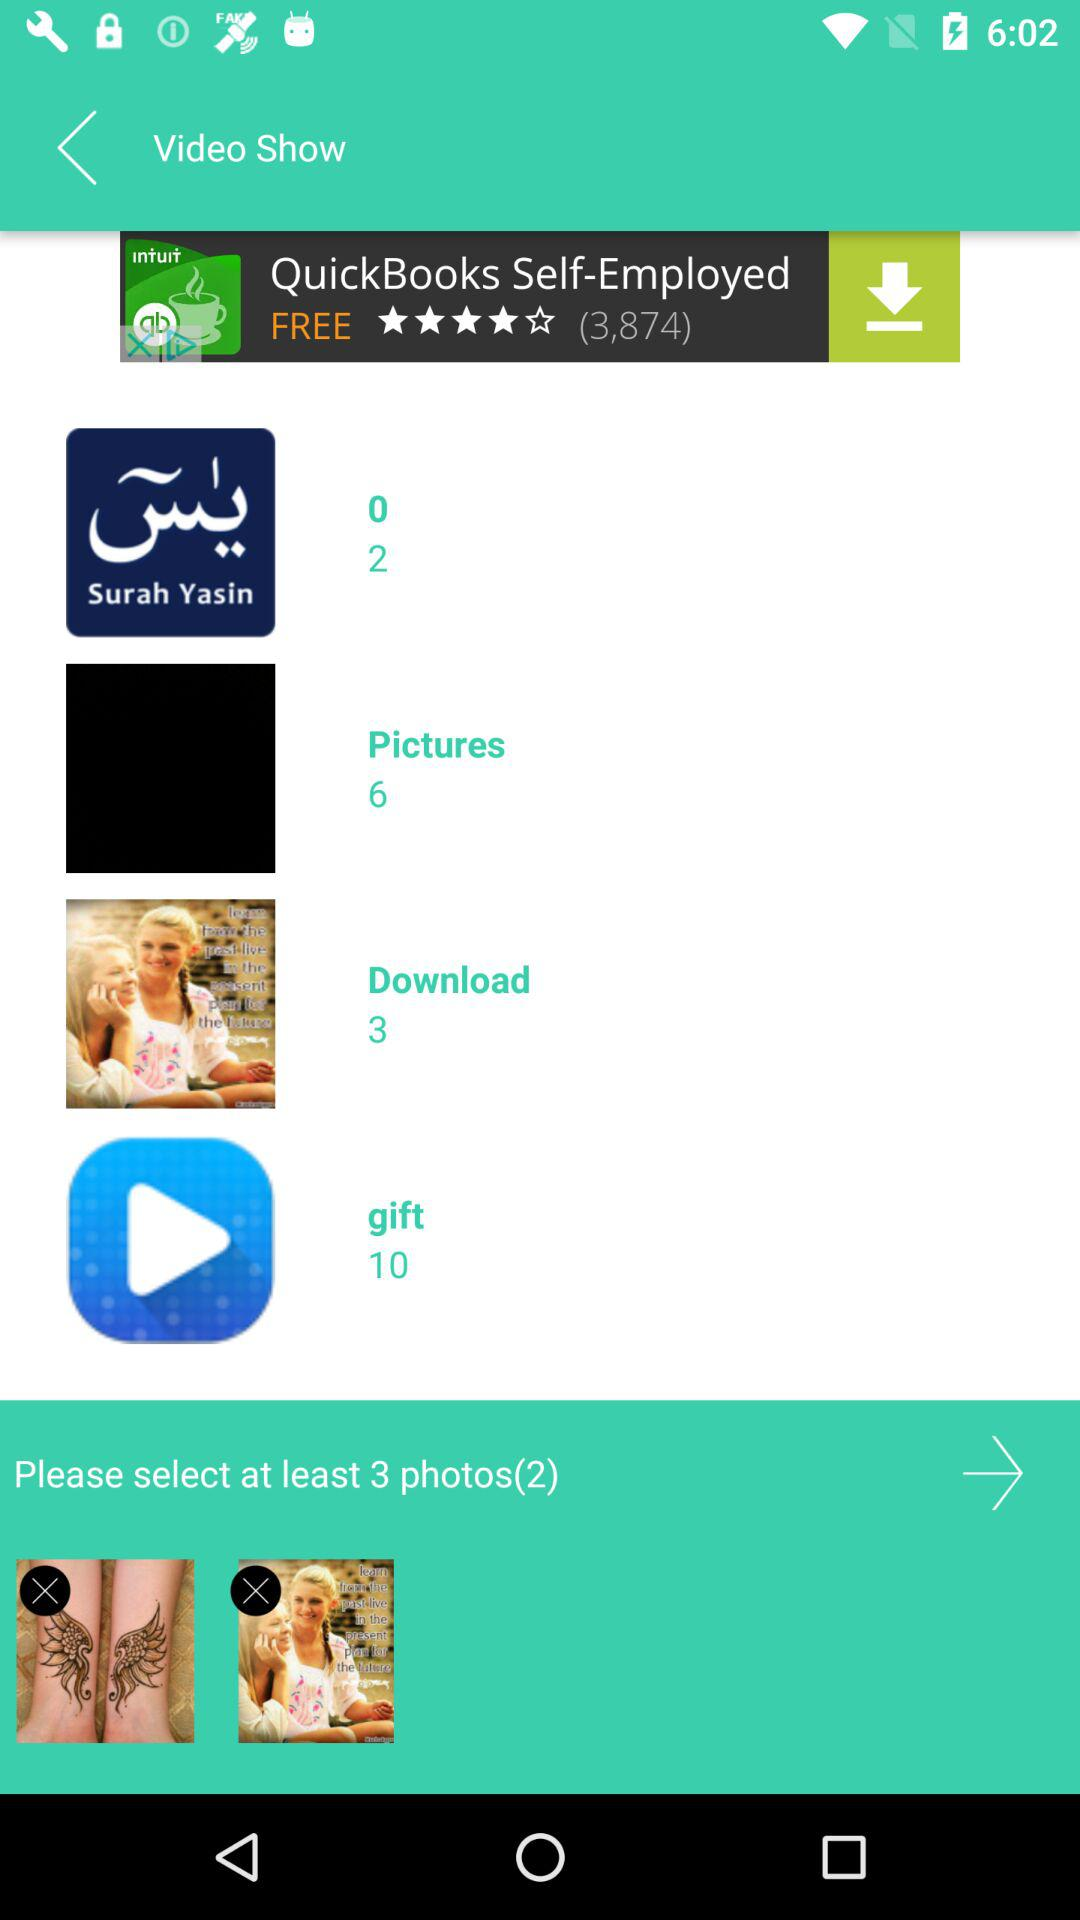How many photos need to be selected for a video show? For a video show, at least 3 photos need to be selected. 